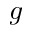Convert formula to latex. <formula><loc_0><loc_0><loc_500><loc_500>g</formula> 